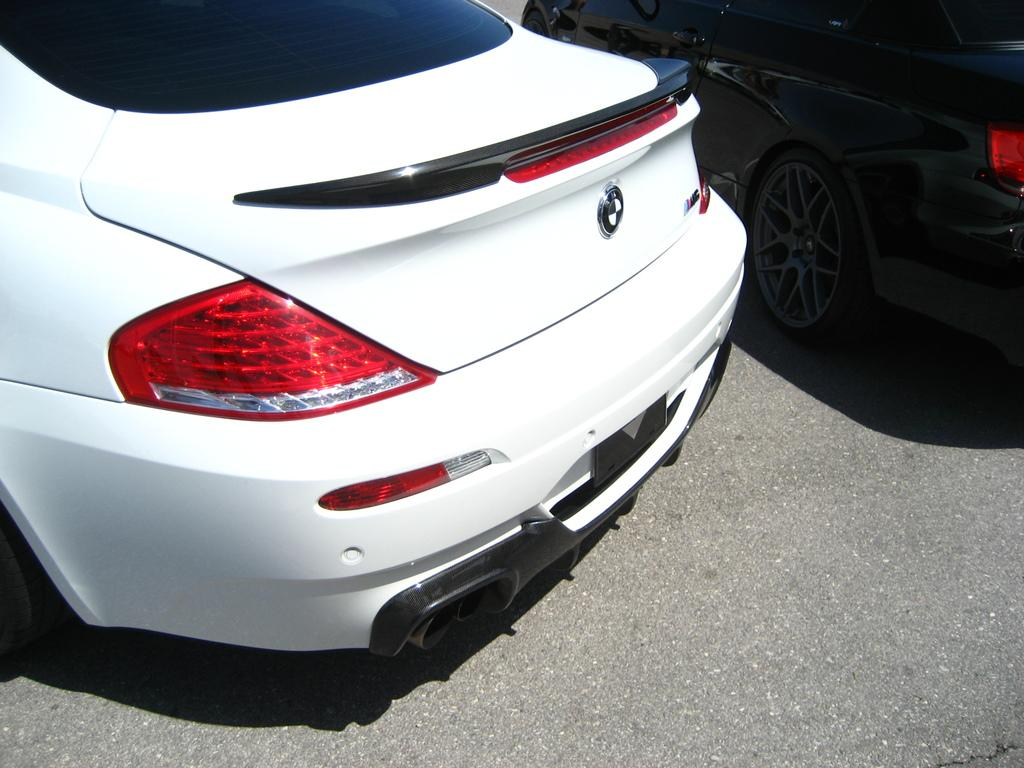How many cars are visible in the image? There are two cars in the image. Where are the cars located? The cars are on the road. What type of learning is taking place at the cemetery in the image? There is no cemetery present in the image, and therefore no learning can be observed. 